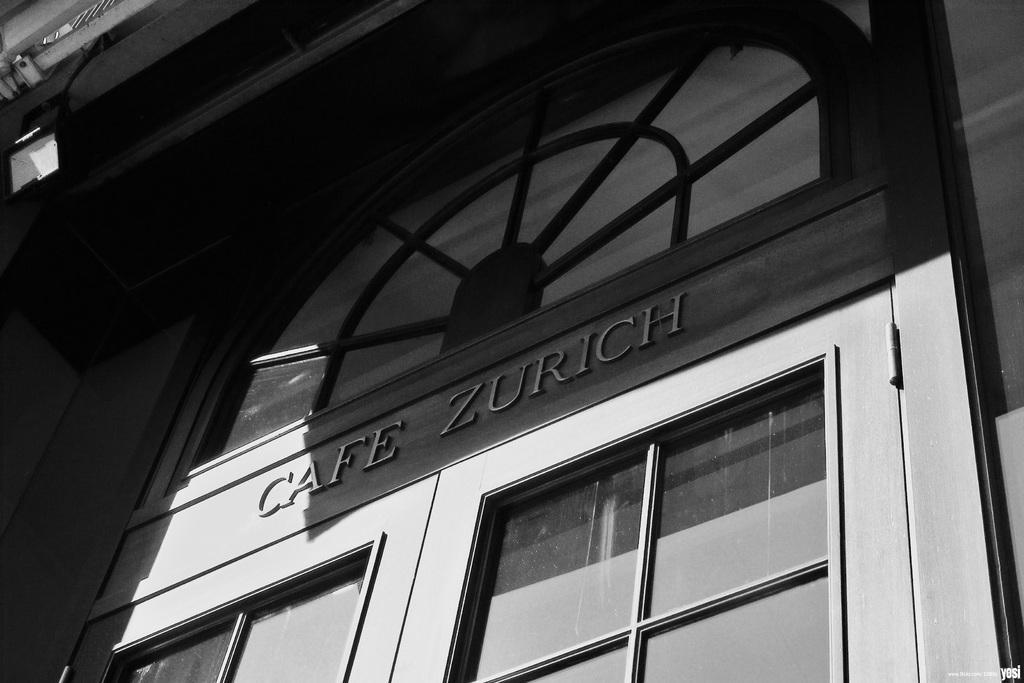Describe this image in one or two sentences. This is a black and white image. There is a door of a building. 